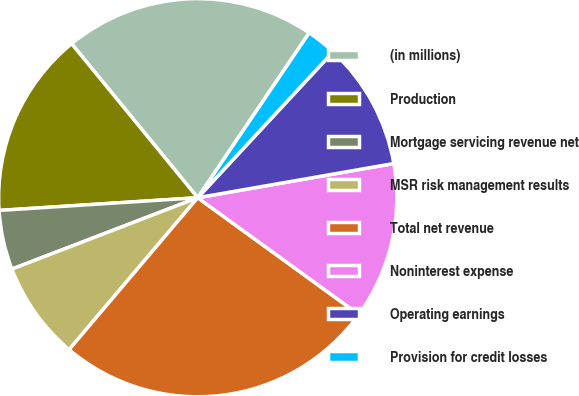Convert chart to OTSL. <chart><loc_0><loc_0><loc_500><loc_500><pie_chart><fcel>(in millions)<fcel>Production<fcel>Mortgage servicing revenue net<fcel>MSR risk management results<fcel>Total net revenue<fcel>Noninterest expense<fcel>Operating earnings<fcel>Provision for credit losses<nl><fcel>20.38%<fcel>15.1%<fcel>4.82%<fcel>7.98%<fcel>26.2%<fcel>12.73%<fcel>10.35%<fcel>2.44%<nl></chart> 